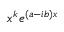Convert formula to latex. <formula><loc_0><loc_0><loc_500><loc_500>x ^ { k } e ^ { ( a - i b ) x }</formula> 